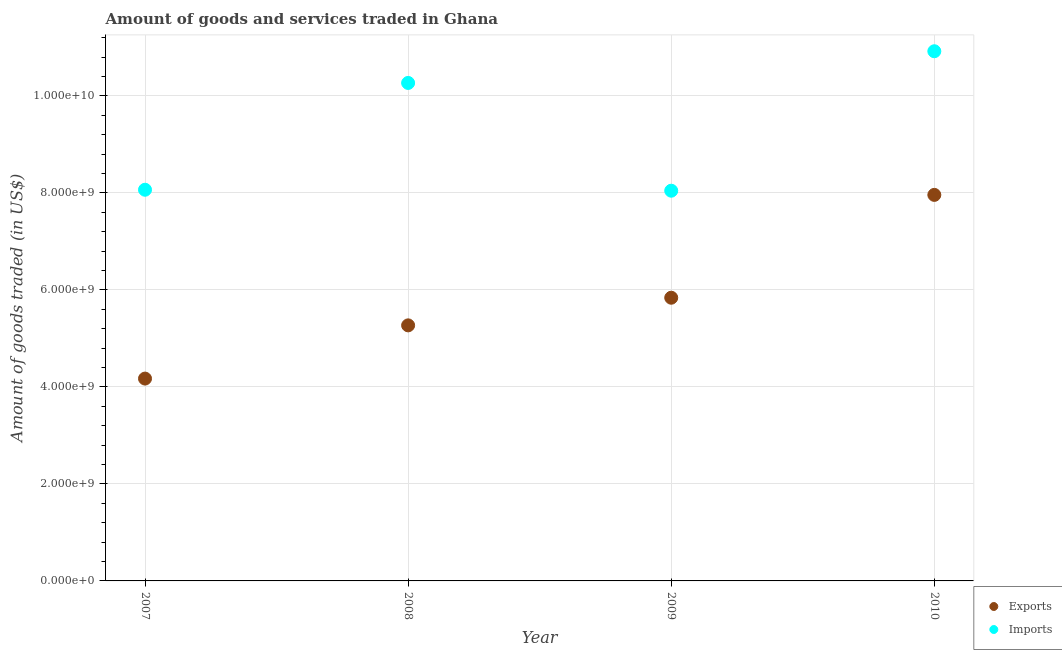Is the number of dotlines equal to the number of legend labels?
Provide a short and direct response. Yes. What is the amount of goods imported in 2007?
Ensure brevity in your answer.  8.07e+09. Across all years, what is the maximum amount of goods exported?
Offer a very short reply. 7.96e+09. Across all years, what is the minimum amount of goods exported?
Provide a short and direct response. 4.17e+09. In which year was the amount of goods imported maximum?
Provide a succinct answer. 2010. In which year was the amount of goods imported minimum?
Your response must be concise. 2009. What is the total amount of goods imported in the graph?
Provide a succinct answer. 3.73e+1. What is the difference between the amount of goods exported in 2008 and that in 2010?
Ensure brevity in your answer.  -2.69e+09. What is the difference between the amount of goods exported in 2007 and the amount of goods imported in 2009?
Provide a short and direct response. -3.87e+09. What is the average amount of goods exported per year?
Offer a very short reply. 5.81e+09. In the year 2007, what is the difference between the amount of goods exported and amount of goods imported?
Make the answer very short. -3.89e+09. In how many years, is the amount of goods exported greater than 10400000000 US$?
Your answer should be compact. 0. What is the ratio of the amount of goods exported in 2007 to that in 2010?
Ensure brevity in your answer.  0.52. Is the amount of goods exported in 2009 less than that in 2010?
Your answer should be very brief. Yes. What is the difference between the highest and the second highest amount of goods imported?
Provide a short and direct response. 6.54e+08. What is the difference between the highest and the lowest amount of goods exported?
Make the answer very short. 3.79e+09. In how many years, is the amount of goods exported greater than the average amount of goods exported taken over all years?
Keep it short and to the point. 2. Is the sum of the amount of goods imported in 2008 and 2010 greater than the maximum amount of goods exported across all years?
Your answer should be very brief. Yes. Does the amount of goods exported monotonically increase over the years?
Offer a terse response. Yes. Is the amount of goods exported strictly less than the amount of goods imported over the years?
Give a very brief answer. Yes. How many dotlines are there?
Your answer should be very brief. 2. What is the difference between two consecutive major ticks on the Y-axis?
Your response must be concise. 2.00e+09. Does the graph contain any zero values?
Keep it short and to the point. No. Does the graph contain grids?
Provide a succinct answer. Yes. Where does the legend appear in the graph?
Provide a short and direct response. Bottom right. How are the legend labels stacked?
Give a very brief answer. Vertical. What is the title of the graph?
Your response must be concise. Amount of goods and services traded in Ghana. Does "Merchandise exports" appear as one of the legend labels in the graph?
Your response must be concise. No. What is the label or title of the Y-axis?
Give a very brief answer. Amount of goods traded (in US$). What is the Amount of goods traded (in US$) of Exports in 2007?
Your answer should be very brief. 4.17e+09. What is the Amount of goods traded (in US$) of Imports in 2007?
Provide a short and direct response. 8.07e+09. What is the Amount of goods traded (in US$) in Exports in 2008?
Provide a succinct answer. 5.27e+09. What is the Amount of goods traded (in US$) in Imports in 2008?
Make the answer very short. 1.03e+1. What is the Amount of goods traded (in US$) in Exports in 2009?
Ensure brevity in your answer.  5.84e+09. What is the Amount of goods traded (in US$) of Imports in 2009?
Provide a succinct answer. 8.05e+09. What is the Amount of goods traded (in US$) in Exports in 2010?
Provide a succinct answer. 7.96e+09. What is the Amount of goods traded (in US$) of Imports in 2010?
Offer a very short reply. 1.09e+1. Across all years, what is the maximum Amount of goods traded (in US$) of Exports?
Your response must be concise. 7.96e+09. Across all years, what is the maximum Amount of goods traded (in US$) of Imports?
Provide a short and direct response. 1.09e+1. Across all years, what is the minimum Amount of goods traded (in US$) of Exports?
Offer a very short reply. 4.17e+09. Across all years, what is the minimum Amount of goods traded (in US$) in Imports?
Offer a very short reply. 8.05e+09. What is the total Amount of goods traded (in US$) of Exports in the graph?
Your answer should be compact. 2.32e+1. What is the total Amount of goods traded (in US$) in Imports in the graph?
Your answer should be very brief. 3.73e+1. What is the difference between the Amount of goods traded (in US$) of Exports in 2007 and that in 2008?
Your answer should be very brief. -1.10e+09. What is the difference between the Amount of goods traded (in US$) of Imports in 2007 and that in 2008?
Provide a short and direct response. -2.20e+09. What is the difference between the Amount of goods traded (in US$) in Exports in 2007 and that in 2009?
Keep it short and to the point. -1.67e+09. What is the difference between the Amount of goods traded (in US$) of Imports in 2007 and that in 2009?
Provide a short and direct response. 1.99e+07. What is the difference between the Amount of goods traded (in US$) of Exports in 2007 and that in 2010?
Provide a succinct answer. -3.79e+09. What is the difference between the Amount of goods traded (in US$) of Imports in 2007 and that in 2010?
Provide a short and direct response. -2.86e+09. What is the difference between the Amount of goods traded (in US$) in Exports in 2008 and that in 2009?
Provide a succinct answer. -5.70e+08. What is the difference between the Amount of goods traded (in US$) of Imports in 2008 and that in 2009?
Give a very brief answer. 2.22e+09. What is the difference between the Amount of goods traded (in US$) of Exports in 2008 and that in 2010?
Provide a succinct answer. -2.69e+09. What is the difference between the Amount of goods traded (in US$) of Imports in 2008 and that in 2010?
Give a very brief answer. -6.54e+08. What is the difference between the Amount of goods traded (in US$) of Exports in 2009 and that in 2010?
Provide a short and direct response. -2.12e+09. What is the difference between the Amount of goods traded (in US$) in Imports in 2009 and that in 2010?
Your answer should be very brief. -2.88e+09. What is the difference between the Amount of goods traded (in US$) of Exports in 2007 and the Amount of goods traded (in US$) of Imports in 2008?
Your answer should be compact. -6.10e+09. What is the difference between the Amount of goods traded (in US$) of Exports in 2007 and the Amount of goods traded (in US$) of Imports in 2009?
Provide a succinct answer. -3.87e+09. What is the difference between the Amount of goods traded (in US$) of Exports in 2007 and the Amount of goods traded (in US$) of Imports in 2010?
Keep it short and to the point. -6.75e+09. What is the difference between the Amount of goods traded (in US$) in Exports in 2008 and the Amount of goods traded (in US$) in Imports in 2009?
Offer a very short reply. -2.78e+09. What is the difference between the Amount of goods traded (in US$) of Exports in 2008 and the Amount of goods traded (in US$) of Imports in 2010?
Offer a very short reply. -5.65e+09. What is the difference between the Amount of goods traded (in US$) in Exports in 2009 and the Amount of goods traded (in US$) in Imports in 2010?
Your response must be concise. -5.08e+09. What is the average Amount of goods traded (in US$) of Exports per year?
Your answer should be very brief. 5.81e+09. What is the average Amount of goods traded (in US$) of Imports per year?
Your answer should be very brief. 9.33e+09. In the year 2007, what is the difference between the Amount of goods traded (in US$) of Exports and Amount of goods traded (in US$) of Imports?
Keep it short and to the point. -3.89e+09. In the year 2008, what is the difference between the Amount of goods traded (in US$) in Exports and Amount of goods traded (in US$) in Imports?
Provide a short and direct response. -5.00e+09. In the year 2009, what is the difference between the Amount of goods traded (in US$) in Exports and Amount of goods traded (in US$) in Imports?
Ensure brevity in your answer.  -2.21e+09. In the year 2010, what is the difference between the Amount of goods traded (in US$) in Exports and Amount of goods traded (in US$) in Imports?
Ensure brevity in your answer.  -2.96e+09. What is the ratio of the Amount of goods traded (in US$) of Exports in 2007 to that in 2008?
Provide a short and direct response. 0.79. What is the ratio of the Amount of goods traded (in US$) in Imports in 2007 to that in 2008?
Provide a short and direct response. 0.79. What is the ratio of the Amount of goods traded (in US$) of Exports in 2007 to that in 2009?
Provide a short and direct response. 0.71. What is the ratio of the Amount of goods traded (in US$) of Imports in 2007 to that in 2009?
Provide a short and direct response. 1. What is the ratio of the Amount of goods traded (in US$) of Exports in 2007 to that in 2010?
Ensure brevity in your answer.  0.52. What is the ratio of the Amount of goods traded (in US$) of Imports in 2007 to that in 2010?
Make the answer very short. 0.74. What is the ratio of the Amount of goods traded (in US$) of Exports in 2008 to that in 2009?
Offer a very short reply. 0.9. What is the ratio of the Amount of goods traded (in US$) of Imports in 2008 to that in 2009?
Make the answer very short. 1.28. What is the ratio of the Amount of goods traded (in US$) in Exports in 2008 to that in 2010?
Give a very brief answer. 0.66. What is the ratio of the Amount of goods traded (in US$) of Imports in 2008 to that in 2010?
Offer a terse response. 0.94. What is the ratio of the Amount of goods traded (in US$) of Exports in 2009 to that in 2010?
Offer a very short reply. 0.73. What is the ratio of the Amount of goods traded (in US$) of Imports in 2009 to that in 2010?
Ensure brevity in your answer.  0.74. What is the difference between the highest and the second highest Amount of goods traded (in US$) of Exports?
Your answer should be compact. 2.12e+09. What is the difference between the highest and the second highest Amount of goods traded (in US$) in Imports?
Your answer should be compact. 6.54e+08. What is the difference between the highest and the lowest Amount of goods traded (in US$) of Exports?
Keep it short and to the point. 3.79e+09. What is the difference between the highest and the lowest Amount of goods traded (in US$) in Imports?
Your answer should be very brief. 2.88e+09. 